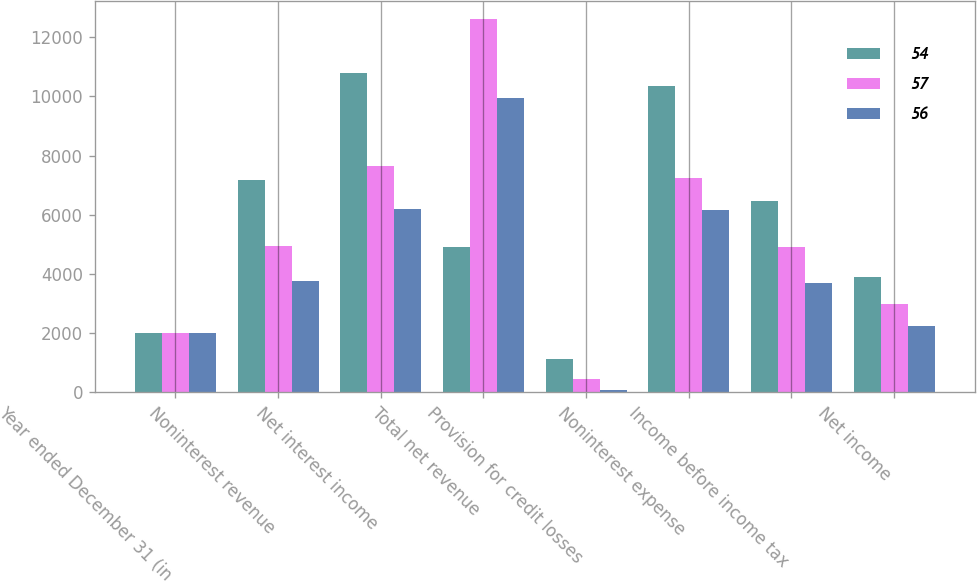<chart> <loc_0><loc_0><loc_500><loc_500><stacked_bar_chart><ecel><fcel>Year ended December 31 (in<fcel>Noninterest revenue<fcel>Net interest income<fcel>Total net revenue<fcel>Provision for credit losses<fcel>Noninterest expense<fcel>Income before income tax<fcel>Net income<nl><fcel>54<fcel>2009<fcel>7169<fcel>10781<fcel>4929<fcel>1142<fcel>10357<fcel>6451<fcel>3903<nl><fcel>57<fcel>2008<fcel>4951<fcel>7659<fcel>12610<fcel>449<fcel>7232<fcel>4929<fcel>2982<nl><fcel>56<fcel>2007<fcel>3763<fcel>6193<fcel>9956<fcel>79<fcel>6166<fcel>3711<fcel>2245<nl></chart> 